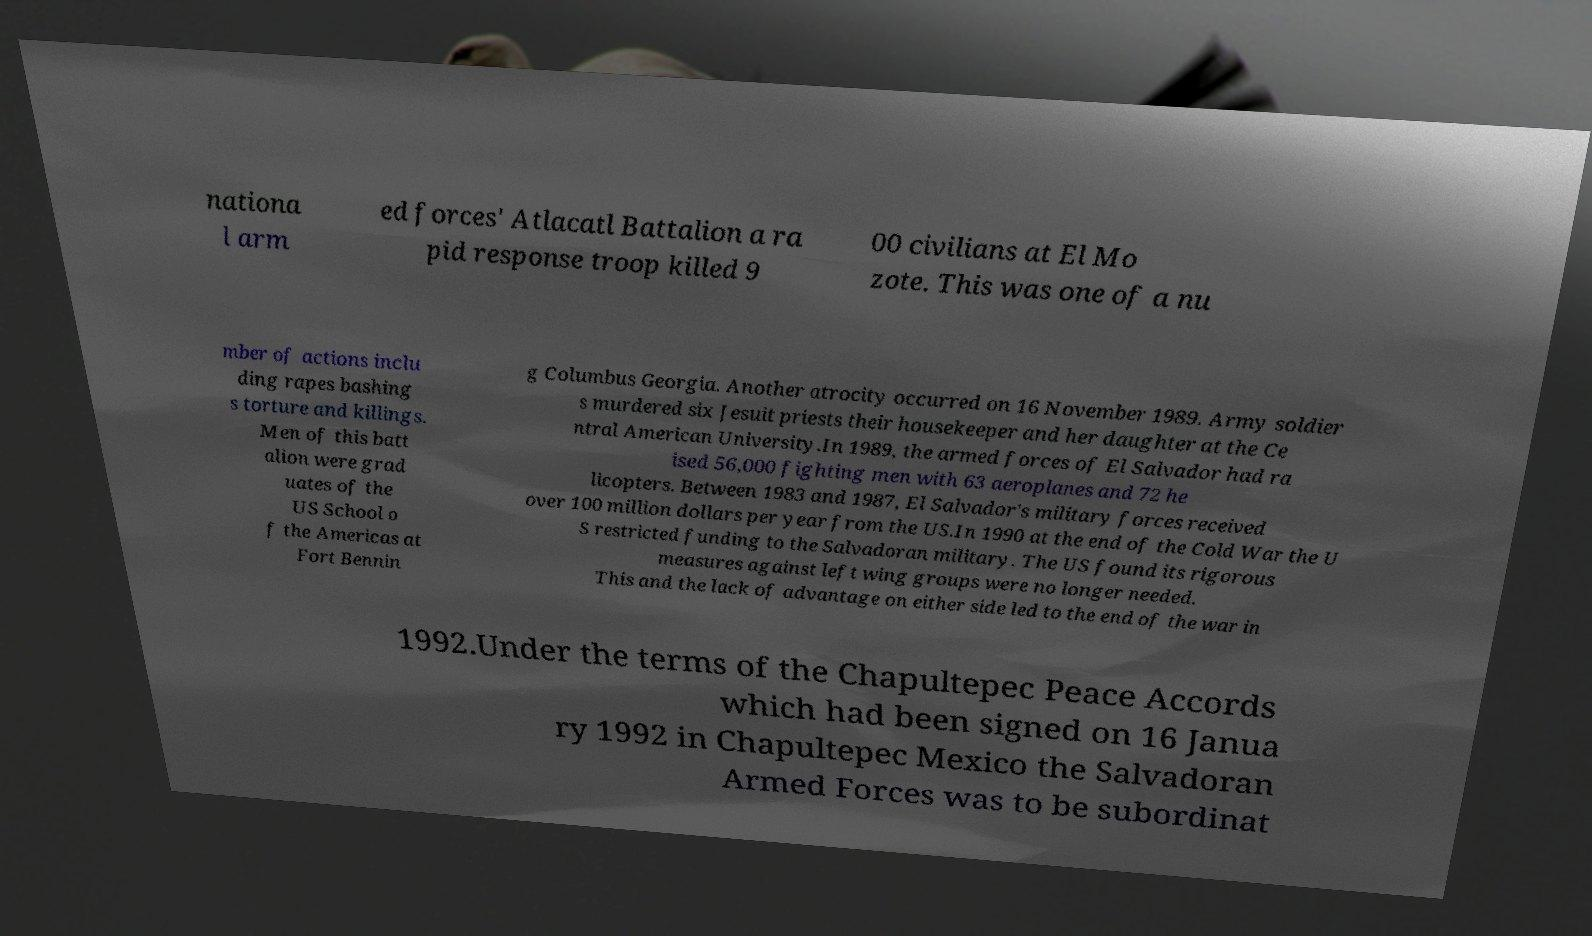Please identify and transcribe the text found in this image. nationa l arm ed forces' Atlacatl Battalion a ra pid response troop killed 9 00 civilians at El Mo zote. This was one of a nu mber of actions inclu ding rapes bashing s torture and killings. Men of this batt alion were grad uates of the US School o f the Americas at Fort Bennin g Columbus Georgia. Another atrocity occurred on 16 November 1989. Army soldier s murdered six Jesuit priests their housekeeper and her daughter at the Ce ntral American University.In 1989, the armed forces of El Salvador had ra ised 56,000 fighting men with 63 aeroplanes and 72 he licopters. Between 1983 and 1987, El Salvador's military forces received over 100 million dollars per year from the US.In 1990 at the end of the Cold War the U S restricted funding to the Salvadoran military. The US found its rigorous measures against left wing groups were no longer needed. This and the lack of advantage on either side led to the end of the war in 1992.Under the terms of the Chapultepec Peace Accords which had been signed on 16 Janua ry 1992 in Chapultepec Mexico the Salvadoran Armed Forces was to be subordinat 